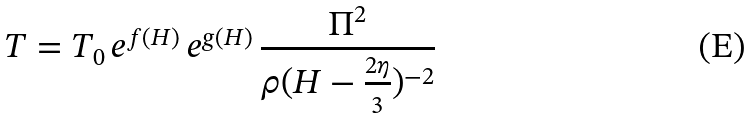<formula> <loc_0><loc_0><loc_500><loc_500>T = T _ { 0 } \, e ^ { f ( H ) } \, e ^ { g ( H ) } \, \frac { \Pi ^ { 2 } } { \rho ( H - \frac { 2 \eta } { 3 } ) ^ { - 2 } }</formula> 